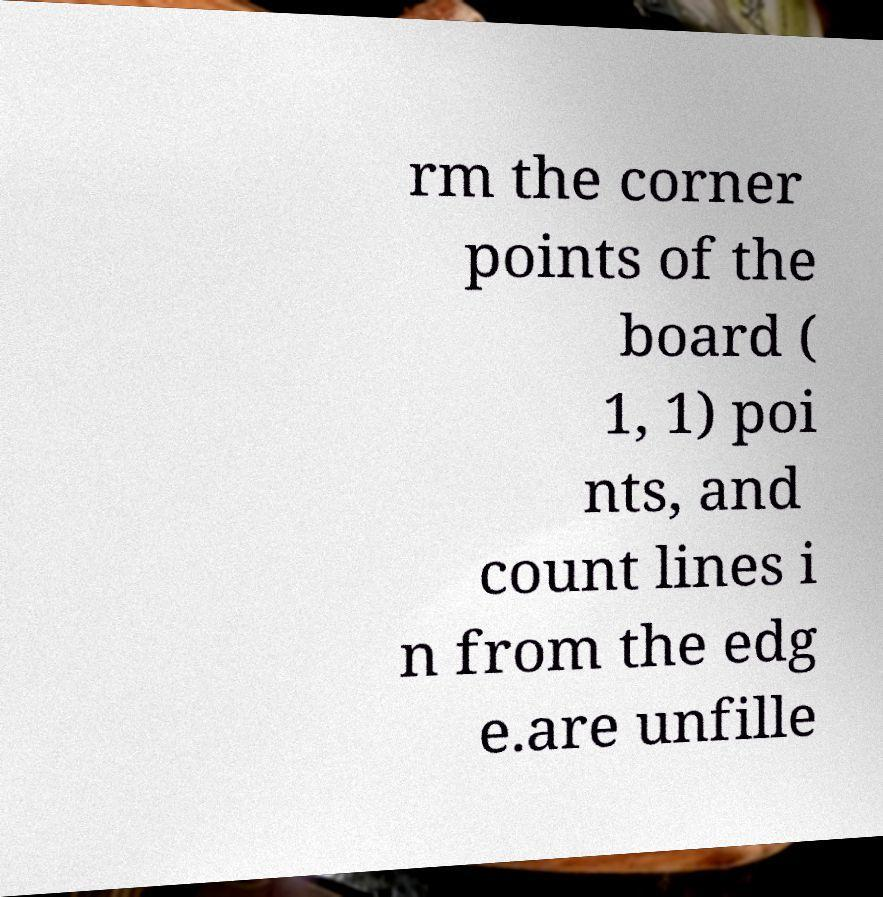Can you read and provide the text displayed in the image?This photo seems to have some interesting text. Can you extract and type it out for me? rm the corner points of the board ( 1, 1) poi nts, and count lines i n from the edg e.are unfille 